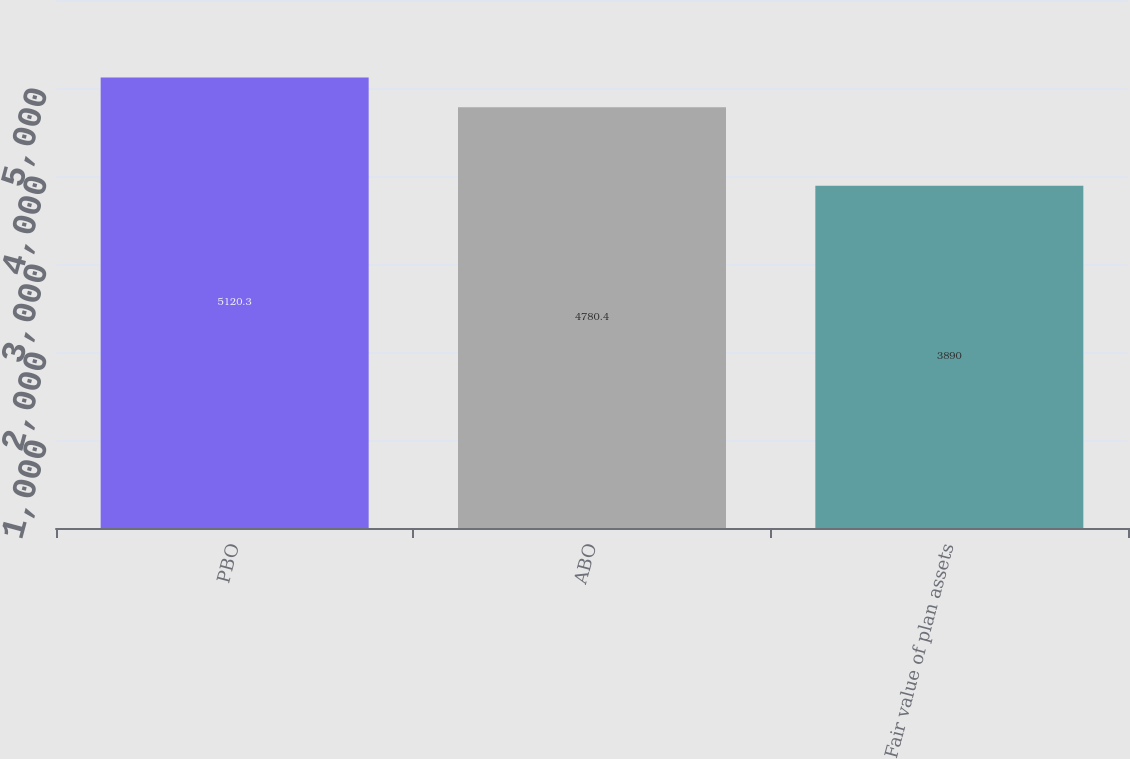Convert chart. <chart><loc_0><loc_0><loc_500><loc_500><bar_chart><fcel>PBO<fcel>ABO<fcel>Fair value of plan assets<nl><fcel>5120.3<fcel>4780.4<fcel>3890<nl></chart> 